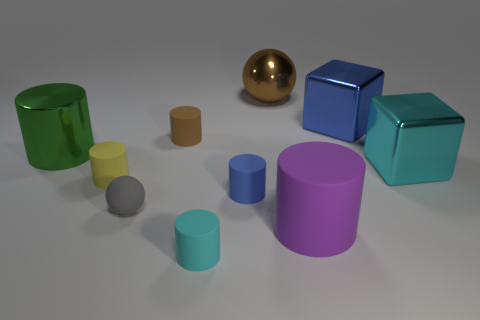Is the shape of the gray thing the same as the large brown metal thing?
Provide a succinct answer. Yes. There is a shiny thing that is to the left of the large purple matte object and to the right of the brown matte cylinder; what is its color?
Your answer should be very brief. Brown. How many rubber objects have the same color as the metal ball?
Offer a very short reply. 1. The metallic sphere that is the same size as the green shiny object is what color?
Your response must be concise. Brown. What is the size of the blue shiny block?
Make the answer very short. Large. What color is the small sphere that is made of the same material as the tiny blue cylinder?
Offer a very short reply. Gray. There is a metallic object that is the same shape as the large purple rubber object; what color is it?
Offer a very short reply. Green. What is the gray ball made of?
Provide a short and direct response. Rubber. There is a green object that is the same shape as the small brown object; what size is it?
Keep it short and to the point. Large. How many other objects are there of the same material as the yellow cylinder?
Your response must be concise. 5. 